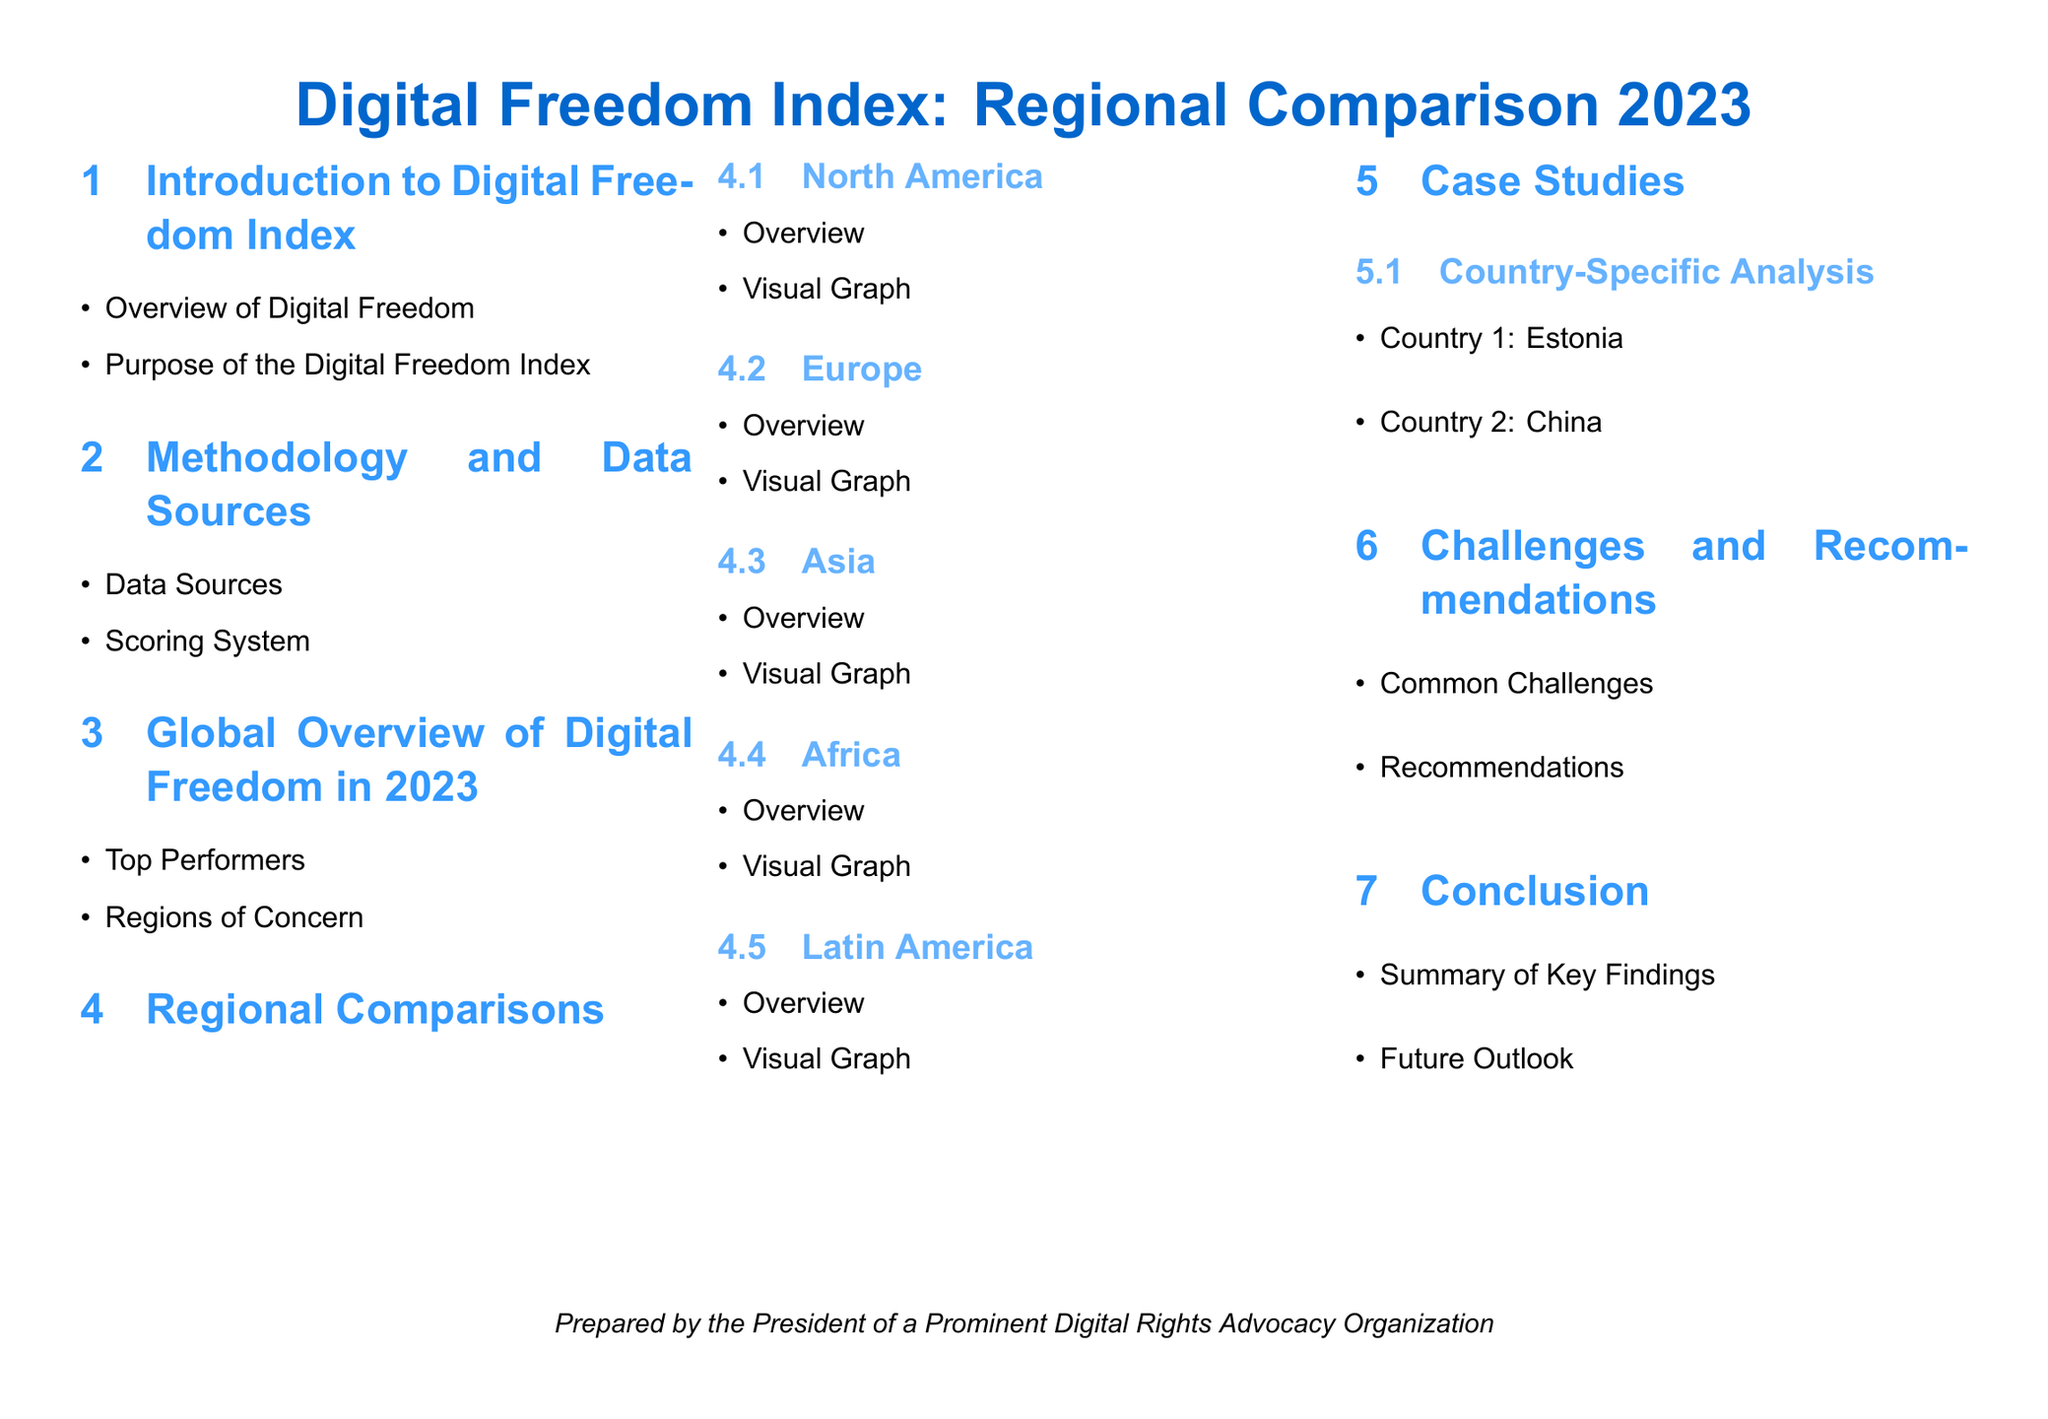What is the title of the document? The title is prominently displayed at the top of the document, highlighting the main focus.
Answer: Digital Freedom Index: Regional Comparison 2023 What is mentioned as the purpose of the Digital Freedom Index? The document specifies the goal of the index within the Introduction section.
Answer: Purpose of the Digital Freedom Index Which region has a dedicated section in the document? Each identified region has its own subsection to provide detailed information.
Answer: North America What is one of the challenges discussed in the document? The Challenges and Recommendations section outlines the issues faced regarding digital freedom.
Answer: Common Challenges Who prepared the document? The document includes a statement on who created it at the bottom.
Answer: The President of a Prominent Digital Rights Advocacy Organization Which country is featured in the case studies? Specific countries are referenced within the case study subsection to illustrate digital freedom.
Answer: Estonia What is the scoring system mentioned in the methodology? The document outlines how scores are assigned based on certain criteria within the methodology section.
Answer: Scoring System How many regions are analyzed for digital freedom? The document lists the regions examined in a structured format.
Answer: Five What are the visual aids used in the document? The document uses visual representations to facilitate understanding of the data.
Answer: Visual Graph What is the concluding section of the document called? The final thoughts and insights are compiled in a designated section toward the end.
Answer: Conclusion 